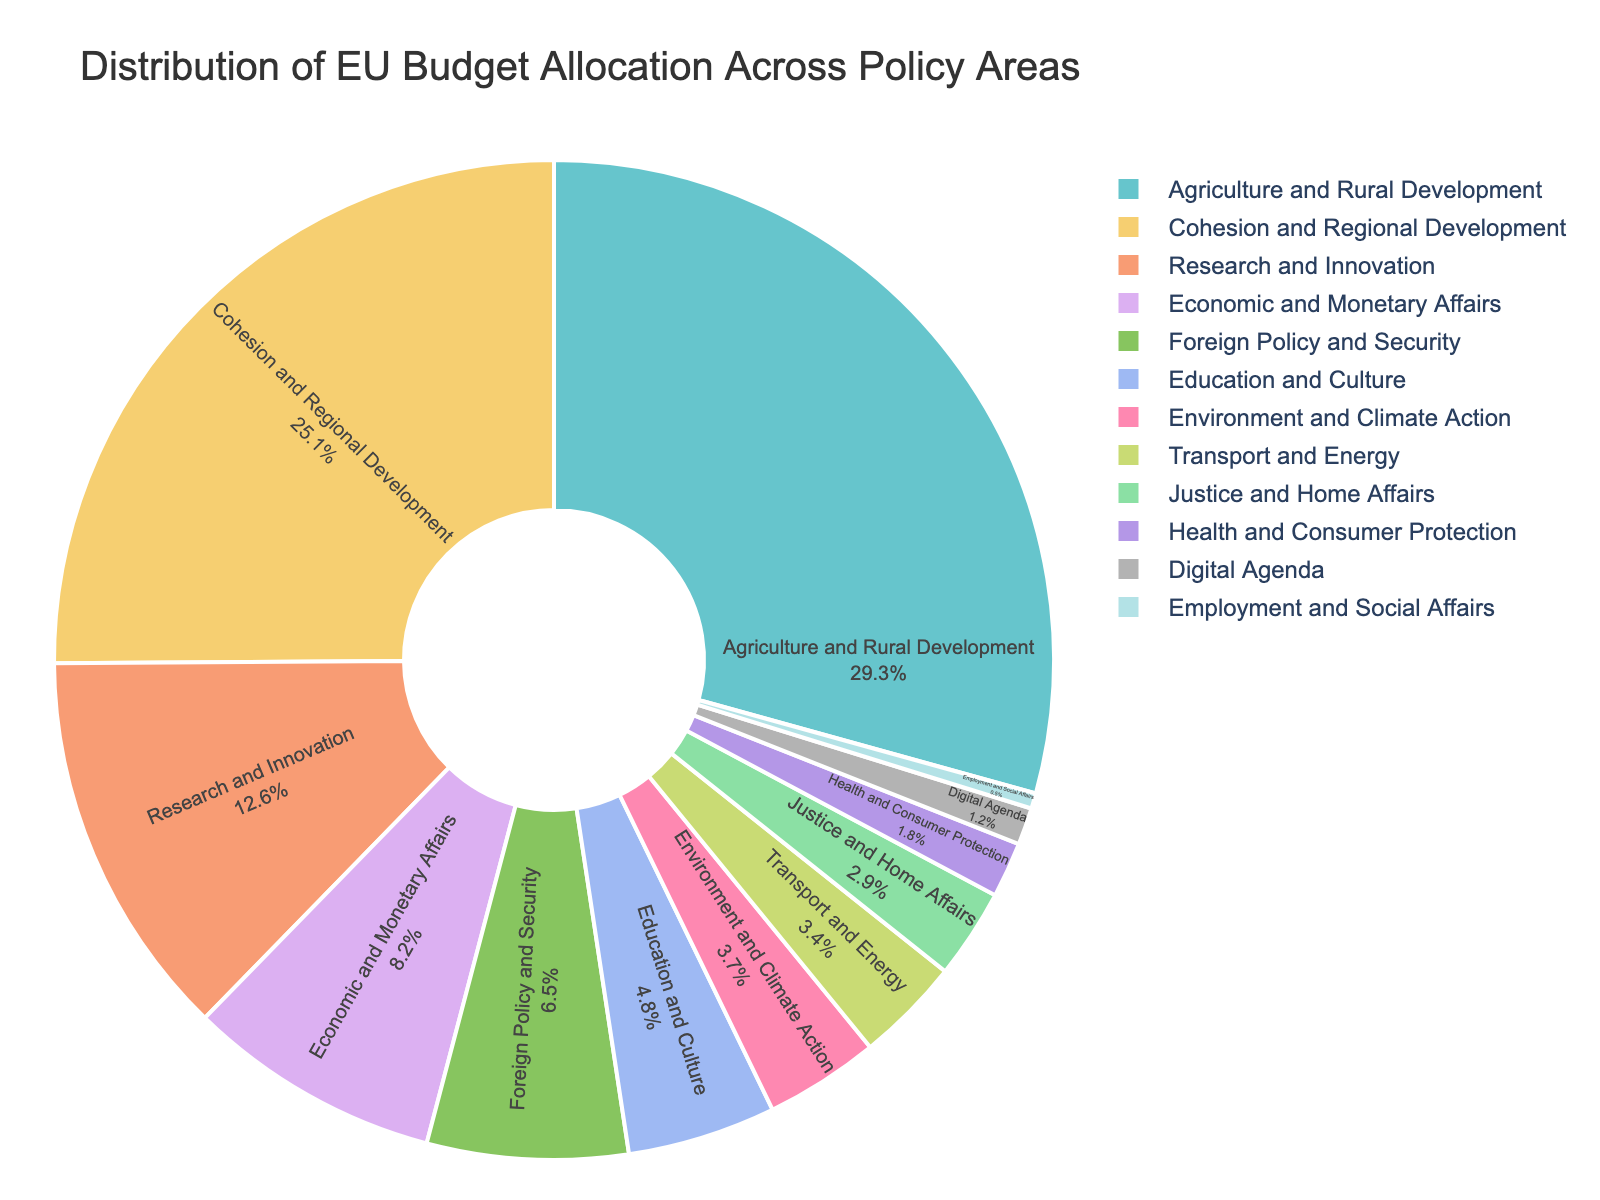What is the policy area with the largest budget allocation? To find the policy area with the largest budget allocation, inspect the pie chart and identify the section with the largest slice. In this case, it is "Agriculture and Rural Development" with 29.3%.
Answer: Agriculture and Rural Development Which policy area has the smallest slice in the pie chart? Look for the smallest section in the pie chart to determine which policy area it represents. The smallest slice is "Employment and Social Affairs" with 0.5%.
Answer: Employment and Social Affairs How much more budget is allocated to Agriculture and Rural Development compared to Digital Agenda? To find the difference, subtract the budget allocation of Digital Agenda from Agriculture and Rural Development: 29.3% - 1.2% = 28.1%.
Answer: 28.1% What percentage of the budget is allocated to Research and Innovation and Education and Culture combined? Add the percentages allocated to Research and Innovation and Education and Culture: 12.6% + 4.8% = 17.4%.
Answer: 17.4% How does the budget allocation for Economic and Monetary Affairs compare to that of Transport and Energy? Compare the percentages of Economic and Monetary Affairs (8.2%) and Transport and Energy (3.4%). Economic and Monetary Affairs has a larger allocation.
Answer: Economic and Monetary Affairs Sum the budget allocation for Health and Consumer Protection, Justice and Home Affairs, and Environment and Climate Action. Add the percentages: 1.8% (Health and Consumer Protection) + 2.9% (Justice and Home Affairs) + 3.7% (Environment and Climate Action) = 8.4%.
Answer: 8.4% What is the average budget allocation of the four policy areas with the smallest allocations? Identify the four areas with the smallest allocations: Employment and Social Affairs (0.5%), Digital Agenda (1.2%), Health and Consumer Protection (1.8%), and Justice and Home Affairs (2.9%). Calculate the average: (0.5% + 1.2% + 1.8% + 2.9%) / 4 = 1.6%.
Answer: 1.6% Compare the total budget allocation for Cohesion and Regional Development and Economic and Monetary Affairs to that of Agriculture and Rural Development. Sum the allocations for Cohesion and Regional Development (25.1%) and Economic and Monetary Affairs (8.2%): 25.1% + 8.2% = 33.3%. Compare with Agriculture and Rural Development (29.3%). Cohesion and Regional Development + Economic and Monetary Affairs have a larger allocation.
Answer: Cohesion and Regional Development + Economic and Monetary Affairs Identify the color associated with Foreign Policy and Security in the pie chart. Inspect the pie chart to see which color represents Foreign Policy and Security (6.5%). For this example, if we assume it is the light blue section, then light blue would be the color.
Answer: Light blue 